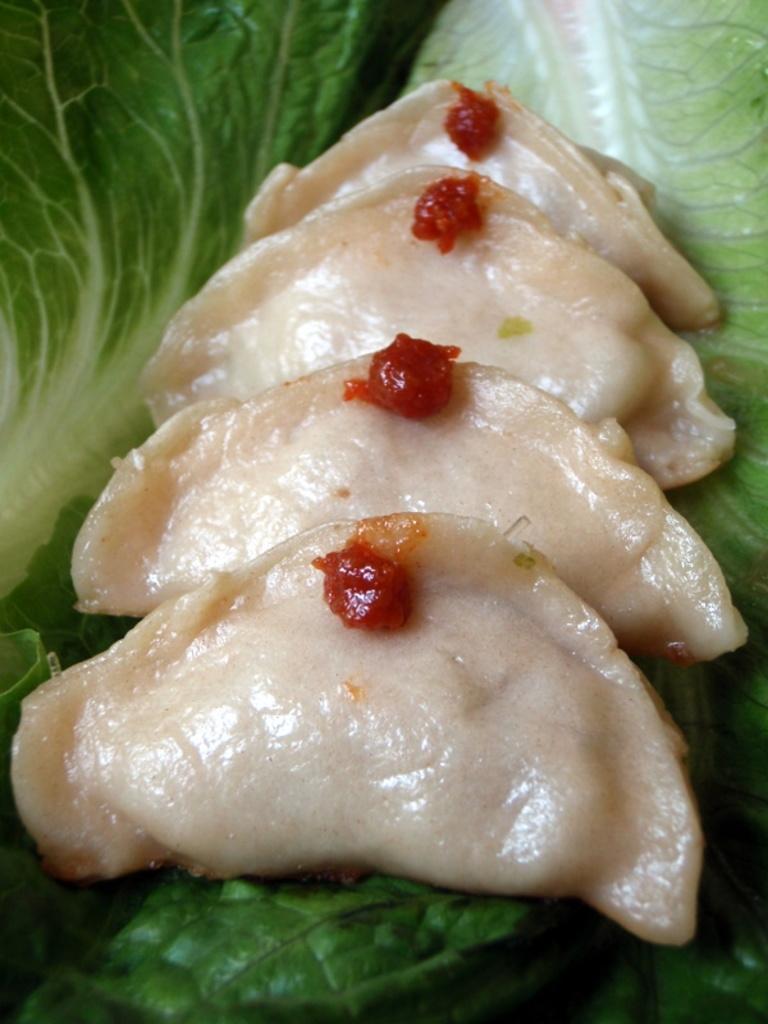Could you give a brief overview of what you see in this image? In this image there is food, there are leaves truncated at the background of the image. 